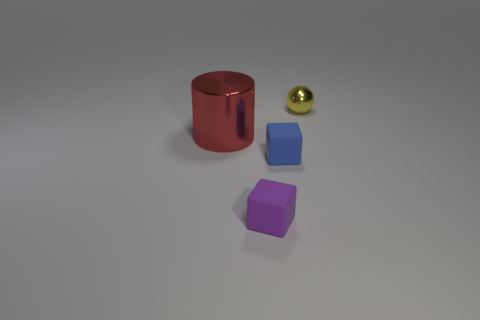Add 2 red objects. How many objects exist? 6 Subtract all cylinders. How many objects are left? 3 Subtract 1 spheres. How many spheres are left? 0 Add 1 big red things. How many big red things are left? 2 Add 1 tiny yellow balls. How many tiny yellow balls exist? 2 Subtract all blue cubes. How many cubes are left? 1 Subtract 0 gray cylinders. How many objects are left? 4 Subtract all purple blocks. Subtract all blue cylinders. How many blocks are left? 1 Subtract all green metal things. Subtract all blue blocks. How many objects are left? 3 